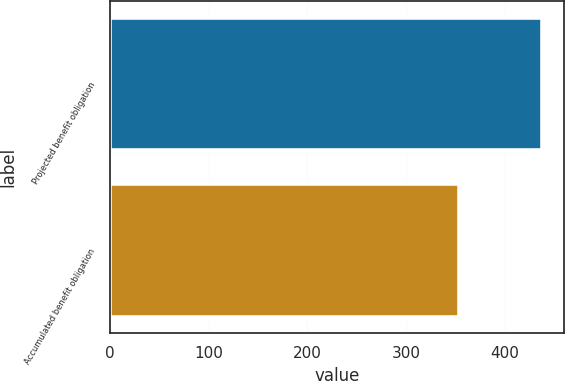Convert chart to OTSL. <chart><loc_0><loc_0><loc_500><loc_500><bar_chart><fcel>Projected benefit obligation<fcel>Accumulated benefit obligation<nl><fcel>438<fcel>354<nl></chart> 